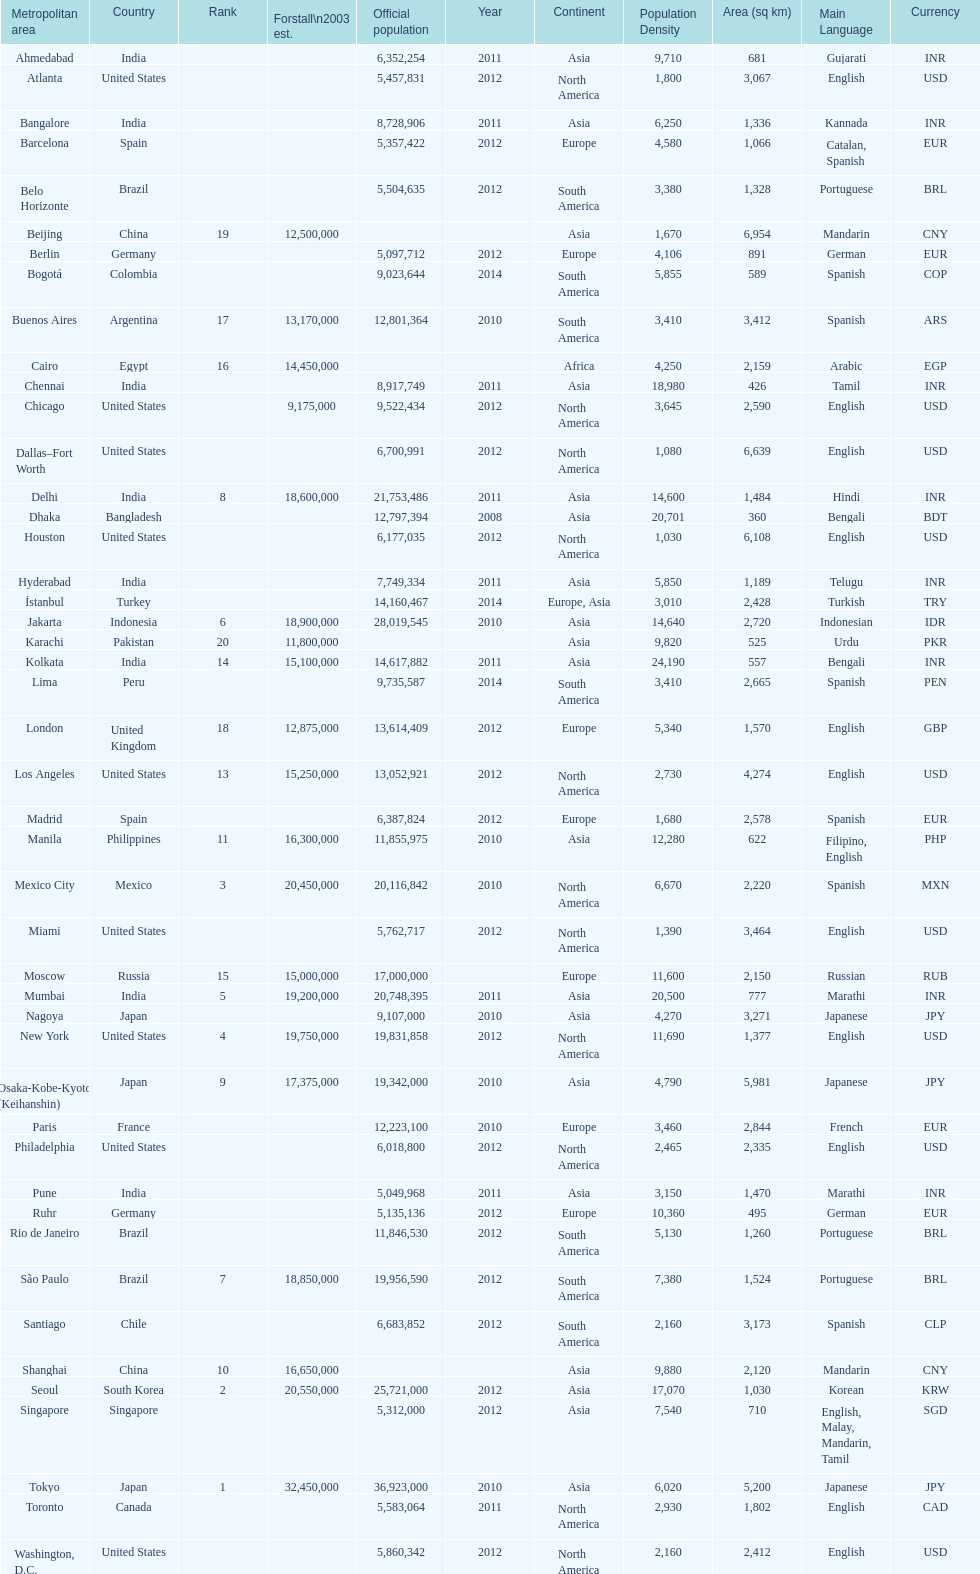Which area is listed above chicago? Chennai. 